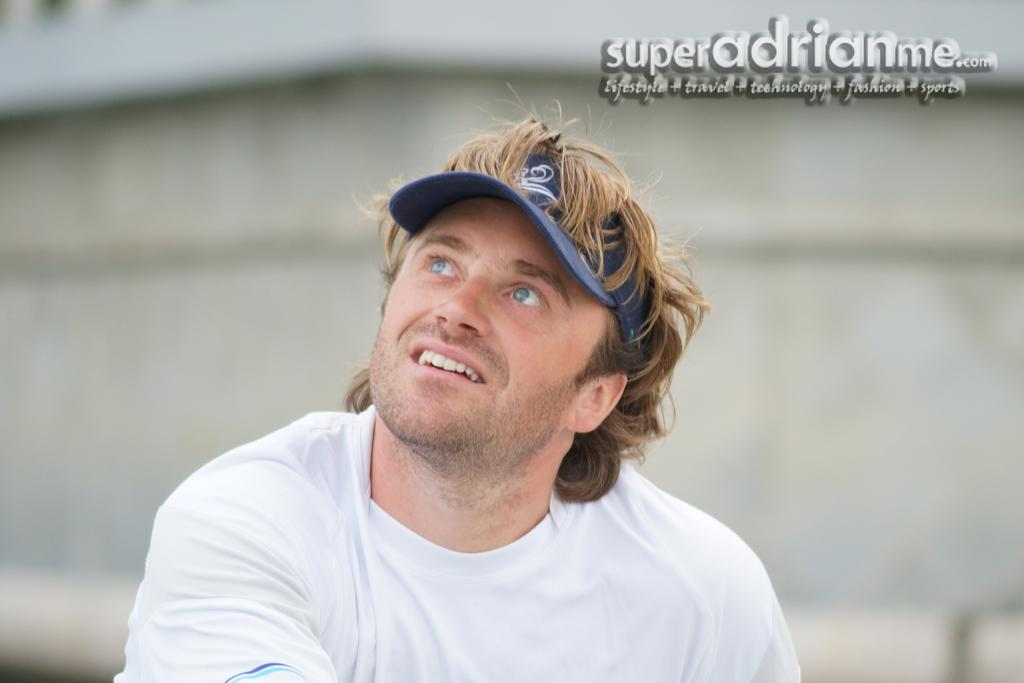What is the primary subject of the image? There is a person sitting in the image. Can you describe the person's position or activity? The person is sitting in the image, but the specific activity or context is not clear from the provided facts. What else can be seen in the image besides the person? There is written text visible at the top of the image. What direction is the person kicking in the image? There is no indication of the person kicking in the image, so it cannot be determined from the provided facts. 